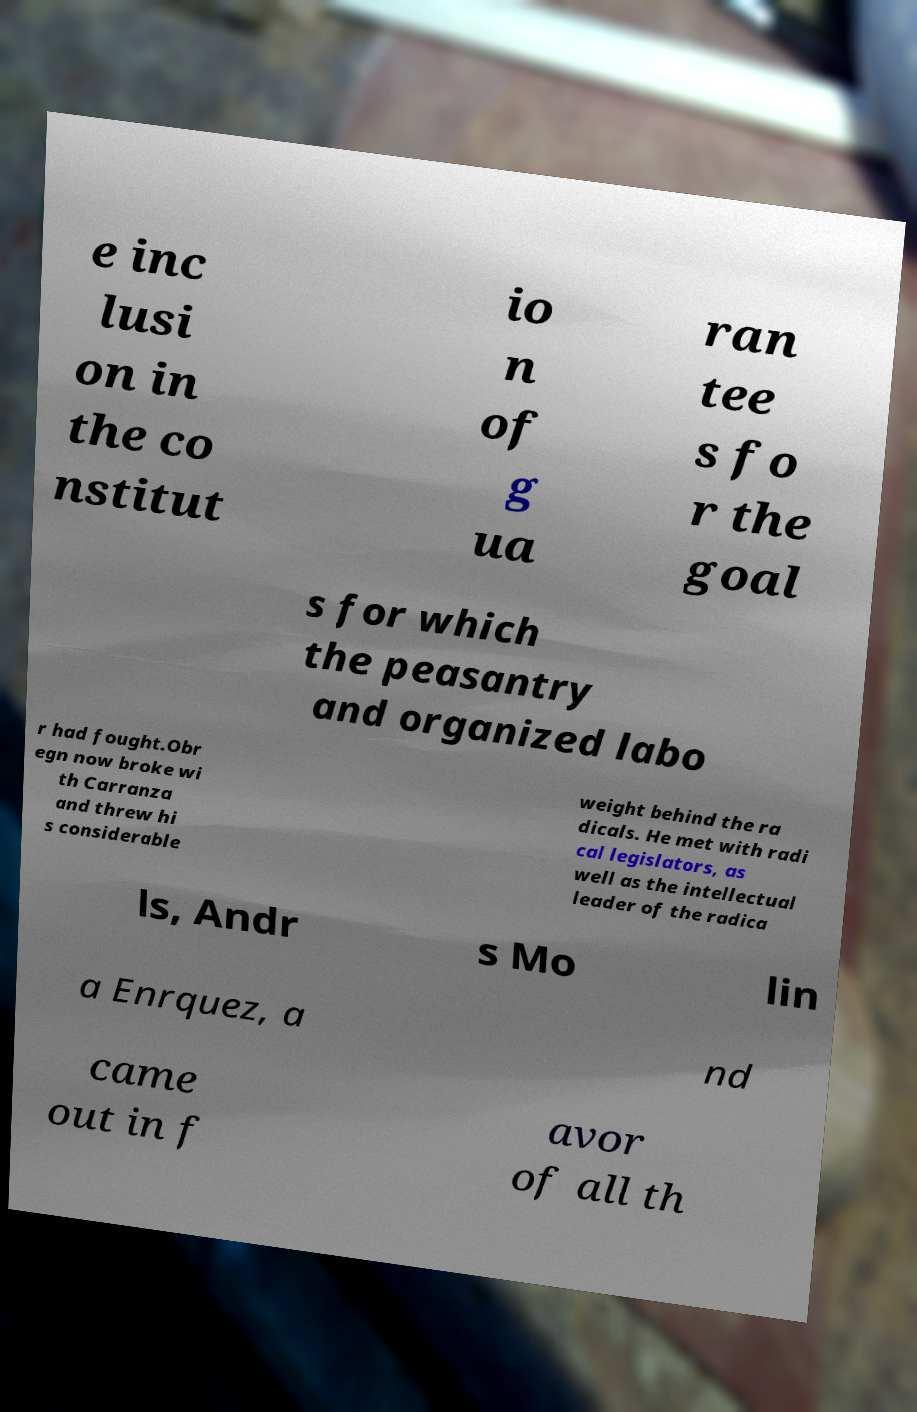I need the written content from this picture converted into text. Can you do that? e inc lusi on in the co nstitut io n of g ua ran tee s fo r the goal s for which the peasantry and organized labo r had fought.Obr egn now broke wi th Carranza and threw hi s considerable weight behind the ra dicals. He met with radi cal legislators, as well as the intellectual leader of the radica ls, Andr s Mo lin a Enrquez, a nd came out in f avor of all th 